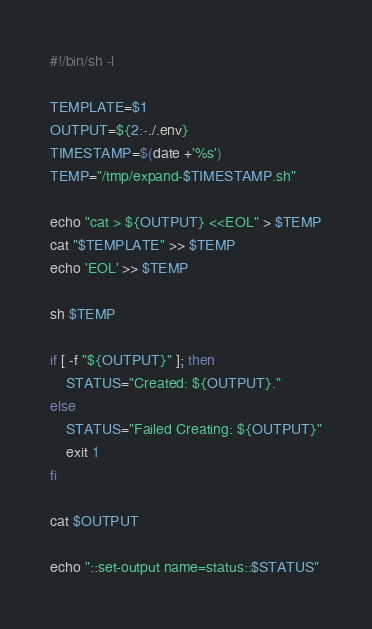<code> <loc_0><loc_0><loc_500><loc_500><_Bash_>#!/bin/sh -l

TEMPLATE=$1
OUTPUT=${2:-./.env}
TIMESTAMP=$(date +'%s')
TEMP="/tmp/expand-$TIMESTAMP.sh"

echo "cat > ${OUTPUT} <<EOL" > $TEMP
cat "$TEMPLATE" >> $TEMP
echo 'EOL' >> $TEMP

sh $TEMP

if [ -f "${OUTPUT}" ]; then
    STATUS="Created: ${OUTPUT}."
else
    STATUS="Failed Creating: ${OUTPUT}"
    exit 1
fi

cat $OUTPUT

echo "::set-output name=status::$STATUS"</code> 